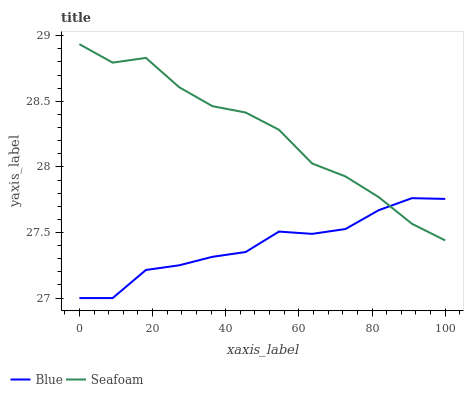Does Blue have the minimum area under the curve?
Answer yes or no. Yes. Does Seafoam have the maximum area under the curve?
Answer yes or no. Yes. Does Seafoam have the minimum area under the curve?
Answer yes or no. No. Is Blue the smoothest?
Answer yes or no. Yes. Is Seafoam the roughest?
Answer yes or no. Yes. Is Seafoam the smoothest?
Answer yes or no. No. Does Blue have the lowest value?
Answer yes or no. Yes. Does Seafoam have the lowest value?
Answer yes or no. No. Does Seafoam have the highest value?
Answer yes or no. Yes. Does Blue intersect Seafoam?
Answer yes or no. Yes. Is Blue less than Seafoam?
Answer yes or no. No. Is Blue greater than Seafoam?
Answer yes or no. No. 